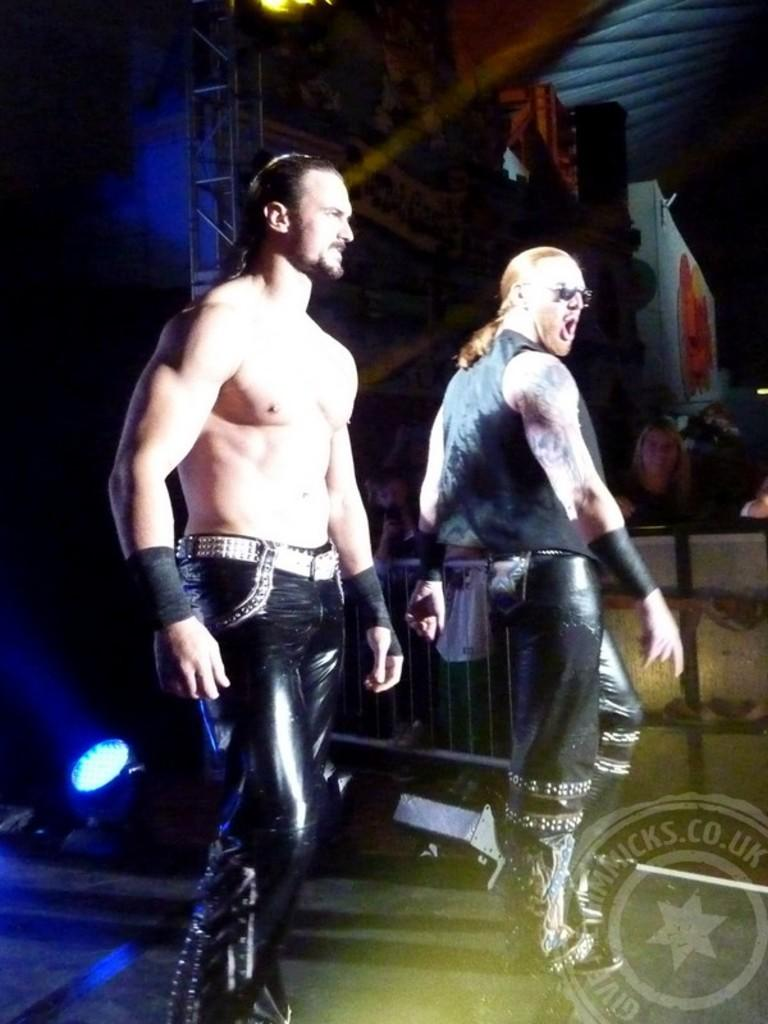How many people are in the image? There are two people in the image. What are the people doing in the image? Both people are standing. What are the people wearing in the image? Both people are wearing black dresses. Can you describe the background of the image? There is a light background and a dark background in the image. What type of sleet is falling in the image? There is no sleet present in the image. How many eggs are visible in the image? There are no eggs visible in the image. 